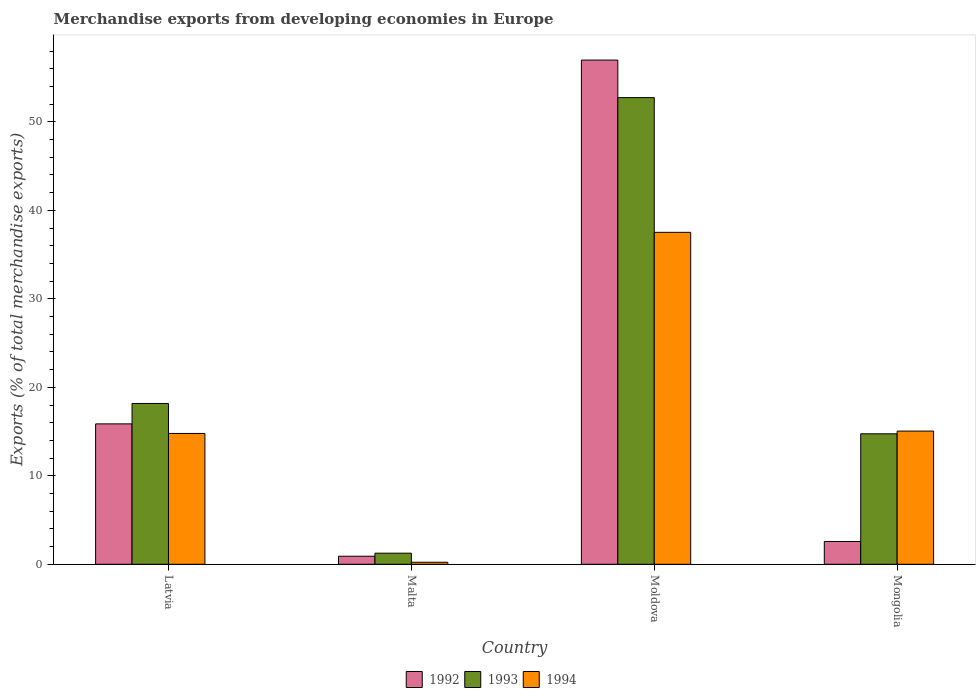How many different coloured bars are there?
Your answer should be compact. 3. How many groups of bars are there?
Offer a very short reply. 4. Are the number of bars per tick equal to the number of legend labels?
Ensure brevity in your answer.  Yes. Are the number of bars on each tick of the X-axis equal?
Provide a succinct answer. Yes. What is the label of the 2nd group of bars from the left?
Your answer should be compact. Malta. In how many cases, is the number of bars for a given country not equal to the number of legend labels?
Give a very brief answer. 0. What is the percentage of total merchandise exports in 1994 in Mongolia?
Keep it short and to the point. 15.05. Across all countries, what is the maximum percentage of total merchandise exports in 1992?
Your answer should be compact. 56.98. Across all countries, what is the minimum percentage of total merchandise exports in 1994?
Your answer should be compact. 0.23. In which country was the percentage of total merchandise exports in 1993 maximum?
Ensure brevity in your answer.  Moldova. In which country was the percentage of total merchandise exports in 1992 minimum?
Your response must be concise. Malta. What is the total percentage of total merchandise exports in 1992 in the graph?
Your response must be concise. 76.33. What is the difference between the percentage of total merchandise exports in 1993 in Moldova and that in Mongolia?
Your answer should be very brief. 37.99. What is the difference between the percentage of total merchandise exports in 1994 in Malta and the percentage of total merchandise exports in 1993 in Latvia?
Provide a succinct answer. -17.94. What is the average percentage of total merchandise exports in 1992 per country?
Provide a short and direct response. 19.08. What is the difference between the percentage of total merchandise exports of/in 1994 and percentage of total merchandise exports of/in 1993 in Latvia?
Ensure brevity in your answer.  -3.39. In how many countries, is the percentage of total merchandise exports in 1993 greater than 14 %?
Offer a very short reply. 3. What is the ratio of the percentage of total merchandise exports in 1994 in Malta to that in Mongolia?
Make the answer very short. 0.02. Is the difference between the percentage of total merchandise exports in 1994 in Moldova and Mongolia greater than the difference between the percentage of total merchandise exports in 1993 in Moldova and Mongolia?
Your response must be concise. No. What is the difference between the highest and the second highest percentage of total merchandise exports in 1993?
Provide a succinct answer. -34.56. What is the difference between the highest and the lowest percentage of total merchandise exports in 1992?
Provide a succinct answer. 56.07. Is it the case that in every country, the sum of the percentage of total merchandise exports in 1994 and percentage of total merchandise exports in 1992 is greater than the percentage of total merchandise exports in 1993?
Offer a very short reply. No. How many bars are there?
Your answer should be very brief. 12. Are all the bars in the graph horizontal?
Give a very brief answer. No. Are the values on the major ticks of Y-axis written in scientific E-notation?
Your response must be concise. No. Does the graph contain any zero values?
Make the answer very short. No. Does the graph contain grids?
Offer a terse response. No. Where does the legend appear in the graph?
Offer a very short reply. Bottom center. What is the title of the graph?
Make the answer very short. Merchandise exports from developing economies in Europe. What is the label or title of the Y-axis?
Ensure brevity in your answer.  Exports (% of total merchandise exports). What is the Exports (% of total merchandise exports) in 1992 in Latvia?
Your response must be concise. 15.87. What is the Exports (% of total merchandise exports) in 1993 in Latvia?
Keep it short and to the point. 18.17. What is the Exports (% of total merchandise exports) in 1994 in Latvia?
Ensure brevity in your answer.  14.79. What is the Exports (% of total merchandise exports) of 1992 in Malta?
Your answer should be compact. 0.91. What is the Exports (% of total merchandise exports) of 1993 in Malta?
Provide a short and direct response. 1.26. What is the Exports (% of total merchandise exports) of 1994 in Malta?
Your response must be concise. 0.23. What is the Exports (% of total merchandise exports) in 1992 in Moldova?
Provide a short and direct response. 56.98. What is the Exports (% of total merchandise exports) in 1993 in Moldova?
Your response must be concise. 52.74. What is the Exports (% of total merchandise exports) of 1994 in Moldova?
Your answer should be compact. 37.51. What is the Exports (% of total merchandise exports) of 1992 in Mongolia?
Keep it short and to the point. 2.57. What is the Exports (% of total merchandise exports) of 1993 in Mongolia?
Make the answer very short. 14.75. What is the Exports (% of total merchandise exports) of 1994 in Mongolia?
Keep it short and to the point. 15.05. Across all countries, what is the maximum Exports (% of total merchandise exports) of 1992?
Give a very brief answer. 56.98. Across all countries, what is the maximum Exports (% of total merchandise exports) of 1993?
Ensure brevity in your answer.  52.74. Across all countries, what is the maximum Exports (% of total merchandise exports) of 1994?
Provide a succinct answer. 37.51. Across all countries, what is the minimum Exports (% of total merchandise exports) of 1992?
Your answer should be very brief. 0.91. Across all countries, what is the minimum Exports (% of total merchandise exports) of 1993?
Offer a very short reply. 1.26. Across all countries, what is the minimum Exports (% of total merchandise exports) in 1994?
Keep it short and to the point. 0.23. What is the total Exports (% of total merchandise exports) of 1992 in the graph?
Provide a succinct answer. 76.33. What is the total Exports (% of total merchandise exports) of 1993 in the graph?
Give a very brief answer. 86.91. What is the total Exports (% of total merchandise exports) in 1994 in the graph?
Keep it short and to the point. 67.58. What is the difference between the Exports (% of total merchandise exports) of 1992 in Latvia and that in Malta?
Provide a short and direct response. 14.96. What is the difference between the Exports (% of total merchandise exports) in 1993 in Latvia and that in Malta?
Your response must be concise. 16.92. What is the difference between the Exports (% of total merchandise exports) in 1994 in Latvia and that in Malta?
Ensure brevity in your answer.  14.56. What is the difference between the Exports (% of total merchandise exports) of 1992 in Latvia and that in Moldova?
Keep it short and to the point. -41.11. What is the difference between the Exports (% of total merchandise exports) of 1993 in Latvia and that in Moldova?
Offer a very short reply. -34.56. What is the difference between the Exports (% of total merchandise exports) of 1994 in Latvia and that in Moldova?
Give a very brief answer. -22.73. What is the difference between the Exports (% of total merchandise exports) in 1992 in Latvia and that in Mongolia?
Offer a terse response. 13.29. What is the difference between the Exports (% of total merchandise exports) in 1993 in Latvia and that in Mongolia?
Provide a short and direct response. 3.43. What is the difference between the Exports (% of total merchandise exports) in 1994 in Latvia and that in Mongolia?
Ensure brevity in your answer.  -0.27. What is the difference between the Exports (% of total merchandise exports) of 1992 in Malta and that in Moldova?
Ensure brevity in your answer.  -56.07. What is the difference between the Exports (% of total merchandise exports) in 1993 in Malta and that in Moldova?
Provide a short and direct response. -51.48. What is the difference between the Exports (% of total merchandise exports) of 1994 in Malta and that in Moldova?
Offer a terse response. -37.28. What is the difference between the Exports (% of total merchandise exports) of 1992 in Malta and that in Mongolia?
Offer a very short reply. -1.66. What is the difference between the Exports (% of total merchandise exports) of 1993 in Malta and that in Mongolia?
Your answer should be very brief. -13.49. What is the difference between the Exports (% of total merchandise exports) of 1994 in Malta and that in Mongolia?
Provide a short and direct response. -14.82. What is the difference between the Exports (% of total merchandise exports) of 1992 in Moldova and that in Mongolia?
Your answer should be compact. 54.4. What is the difference between the Exports (% of total merchandise exports) of 1993 in Moldova and that in Mongolia?
Provide a short and direct response. 37.99. What is the difference between the Exports (% of total merchandise exports) of 1994 in Moldova and that in Mongolia?
Make the answer very short. 22.46. What is the difference between the Exports (% of total merchandise exports) of 1992 in Latvia and the Exports (% of total merchandise exports) of 1993 in Malta?
Your response must be concise. 14.61. What is the difference between the Exports (% of total merchandise exports) of 1992 in Latvia and the Exports (% of total merchandise exports) of 1994 in Malta?
Your response must be concise. 15.64. What is the difference between the Exports (% of total merchandise exports) in 1993 in Latvia and the Exports (% of total merchandise exports) in 1994 in Malta?
Provide a short and direct response. 17.94. What is the difference between the Exports (% of total merchandise exports) in 1992 in Latvia and the Exports (% of total merchandise exports) in 1993 in Moldova?
Give a very brief answer. -36.87. What is the difference between the Exports (% of total merchandise exports) in 1992 in Latvia and the Exports (% of total merchandise exports) in 1994 in Moldova?
Provide a short and direct response. -21.65. What is the difference between the Exports (% of total merchandise exports) in 1993 in Latvia and the Exports (% of total merchandise exports) in 1994 in Moldova?
Your response must be concise. -19.34. What is the difference between the Exports (% of total merchandise exports) of 1992 in Latvia and the Exports (% of total merchandise exports) of 1993 in Mongolia?
Your answer should be compact. 1.12. What is the difference between the Exports (% of total merchandise exports) of 1992 in Latvia and the Exports (% of total merchandise exports) of 1994 in Mongolia?
Your response must be concise. 0.81. What is the difference between the Exports (% of total merchandise exports) of 1993 in Latvia and the Exports (% of total merchandise exports) of 1994 in Mongolia?
Your response must be concise. 3.12. What is the difference between the Exports (% of total merchandise exports) in 1992 in Malta and the Exports (% of total merchandise exports) in 1993 in Moldova?
Keep it short and to the point. -51.83. What is the difference between the Exports (% of total merchandise exports) of 1992 in Malta and the Exports (% of total merchandise exports) of 1994 in Moldova?
Give a very brief answer. -36.6. What is the difference between the Exports (% of total merchandise exports) of 1993 in Malta and the Exports (% of total merchandise exports) of 1994 in Moldova?
Make the answer very short. -36.26. What is the difference between the Exports (% of total merchandise exports) in 1992 in Malta and the Exports (% of total merchandise exports) in 1993 in Mongolia?
Your response must be concise. -13.84. What is the difference between the Exports (% of total merchandise exports) in 1992 in Malta and the Exports (% of total merchandise exports) in 1994 in Mongolia?
Your answer should be very brief. -14.14. What is the difference between the Exports (% of total merchandise exports) in 1993 in Malta and the Exports (% of total merchandise exports) in 1994 in Mongolia?
Give a very brief answer. -13.8. What is the difference between the Exports (% of total merchandise exports) of 1992 in Moldova and the Exports (% of total merchandise exports) of 1993 in Mongolia?
Your answer should be very brief. 42.23. What is the difference between the Exports (% of total merchandise exports) of 1992 in Moldova and the Exports (% of total merchandise exports) of 1994 in Mongolia?
Your response must be concise. 41.93. What is the difference between the Exports (% of total merchandise exports) of 1993 in Moldova and the Exports (% of total merchandise exports) of 1994 in Mongolia?
Provide a short and direct response. 37.69. What is the average Exports (% of total merchandise exports) of 1992 per country?
Your answer should be compact. 19.08. What is the average Exports (% of total merchandise exports) of 1993 per country?
Keep it short and to the point. 21.73. What is the average Exports (% of total merchandise exports) in 1994 per country?
Provide a short and direct response. 16.89. What is the difference between the Exports (% of total merchandise exports) in 1992 and Exports (% of total merchandise exports) in 1993 in Latvia?
Provide a short and direct response. -2.31. What is the difference between the Exports (% of total merchandise exports) of 1992 and Exports (% of total merchandise exports) of 1994 in Latvia?
Your answer should be compact. 1.08. What is the difference between the Exports (% of total merchandise exports) of 1993 and Exports (% of total merchandise exports) of 1994 in Latvia?
Provide a succinct answer. 3.39. What is the difference between the Exports (% of total merchandise exports) in 1992 and Exports (% of total merchandise exports) in 1993 in Malta?
Ensure brevity in your answer.  -0.34. What is the difference between the Exports (% of total merchandise exports) of 1992 and Exports (% of total merchandise exports) of 1994 in Malta?
Provide a short and direct response. 0.68. What is the difference between the Exports (% of total merchandise exports) of 1993 and Exports (% of total merchandise exports) of 1994 in Malta?
Provide a short and direct response. 1.03. What is the difference between the Exports (% of total merchandise exports) of 1992 and Exports (% of total merchandise exports) of 1993 in Moldova?
Provide a short and direct response. 4.24. What is the difference between the Exports (% of total merchandise exports) in 1992 and Exports (% of total merchandise exports) in 1994 in Moldova?
Offer a terse response. 19.47. What is the difference between the Exports (% of total merchandise exports) in 1993 and Exports (% of total merchandise exports) in 1994 in Moldova?
Your answer should be compact. 15.22. What is the difference between the Exports (% of total merchandise exports) of 1992 and Exports (% of total merchandise exports) of 1993 in Mongolia?
Your answer should be compact. -12.17. What is the difference between the Exports (% of total merchandise exports) of 1992 and Exports (% of total merchandise exports) of 1994 in Mongolia?
Your answer should be very brief. -12.48. What is the difference between the Exports (% of total merchandise exports) of 1993 and Exports (% of total merchandise exports) of 1994 in Mongolia?
Give a very brief answer. -0.31. What is the ratio of the Exports (% of total merchandise exports) in 1992 in Latvia to that in Malta?
Provide a short and direct response. 17.43. What is the ratio of the Exports (% of total merchandise exports) of 1993 in Latvia to that in Malta?
Your response must be concise. 14.48. What is the ratio of the Exports (% of total merchandise exports) of 1994 in Latvia to that in Malta?
Provide a succinct answer. 64.38. What is the ratio of the Exports (% of total merchandise exports) of 1992 in Latvia to that in Moldova?
Ensure brevity in your answer.  0.28. What is the ratio of the Exports (% of total merchandise exports) of 1993 in Latvia to that in Moldova?
Ensure brevity in your answer.  0.34. What is the ratio of the Exports (% of total merchandise exports) of 1994 in Latvia to that in Moldova?
Your response must be concise. 0.39. What is the ratio of the Exports (% of total merchandise exports) of 1992 in Latvia to that in Mongolia?
Make the answer very short. 6.16. What is the ratio of the Exports (% of total merchandise exports) in 1993 in Latvia to that in Mongolia?
Offer a very short reply. 1.23. What is the ratio of the Exports (% of total merchandise exports) in 1994 in Latvia to that in Mongolia?
Make the answer very short. 0.98. What is the ratio of the Exports (% of total merchandise exports) in 1992 in Malta to that in Moldova?
Provide a succinct answer. 0.02. What is the ratio of the Exports (% of total merchandise exports) of 1993 in Malta to that in Moldova?
Your answer should be compact. 0.02. What is the ratio of the Exports (% of total merchandise exports) in 1994 in Malta to that in Moldova?
Give a very brief answer. 0.01. What is the ratio of the Exports (% of total merchandise exports) in 1992 in Malta to that in Mongolia?
Your response must be concise. 0.35. What is the ratio of the Exports (% of total merchandise exports) in 1993 in Malta to that in Mongolia?
Your answer should be very brief. 0.09. What is the ratio of the Exports (% of total merchandise exports) in 1994 in Malta to that in Mongolia?
Provide a succinct answer. 0.02. What is the ratio of the Exports (% of total merchandise exports) in 1992 in Moldova to that in Mongolia?
Your response must be concise. 22.13. What is the ratio of the Exports (% of total merchandise exports) in 1993 in Moldova to that in Mongolia?
Offer a very short reply. 3.58. What is the ratio of the Exports (% of total merchandise exports) in 1994 in Moldova to that in Mongolia?
Make the answer very short. 2.49. What is the difference between the highest and the second highest Exports (% of total merchandise exports) of 1992?
Your answer should be compact. 41.11. What is the difference between the highest and the second highest Exports (% of total merchandise exports) in 1993?
Give a very brief answer. 34.56. What is the difference between the highest and the second highest Exports (% of total merchandise exports) in 1994?
Your answer should be very brief. 22.46. What is the difference between the highest and the lowest Exports (% of total merchandise exports) of 1992?
Keep it short and to the point. 56.07. What is the difference between the highest and the lowest Exports (% of total merchandise exports) in 1993?
Your response must be concise. 51.48. What is the difference between the highest and the lowest Exports (% of total merchandise exports) of 1994?
Give a very brief answer. 37.28. 